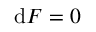<formula> <loc_0><loc_0><loc_500><loc_500>d F = 0</formula> 